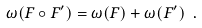Convert formula to latex. <formula><loc_0><loc_0><loc_500><loc_500>\omega ( F \circ F ^ { \prime } ) = \omega ( F ) + \omega ( F ^ { \prime } ) \ .</formula> 